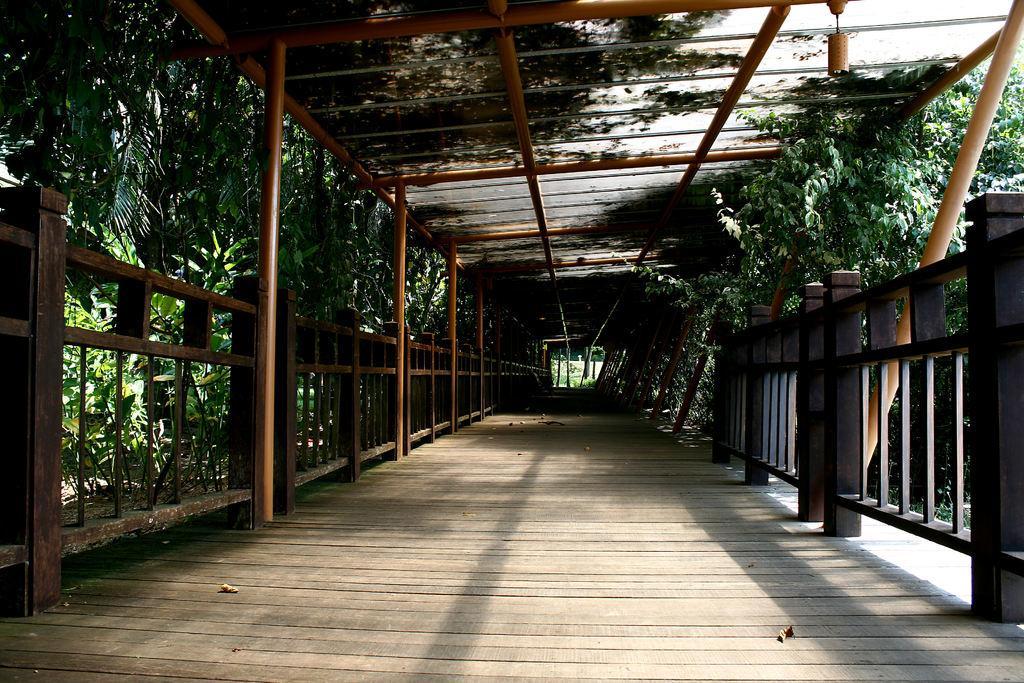Could you give a brief overview of what you see in this image? In this image we can see a fencing, poles, trees. At the bottom, there is a wooden floor. Top of the image, we can see a roof with rods. 